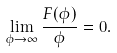<formula> <loc_0><loc_0><loc_500><loc_500>\lim _ { \phi \rightarrow \infty } \frac { F ( \phi ) } { \phi } = 0 .</formula> 